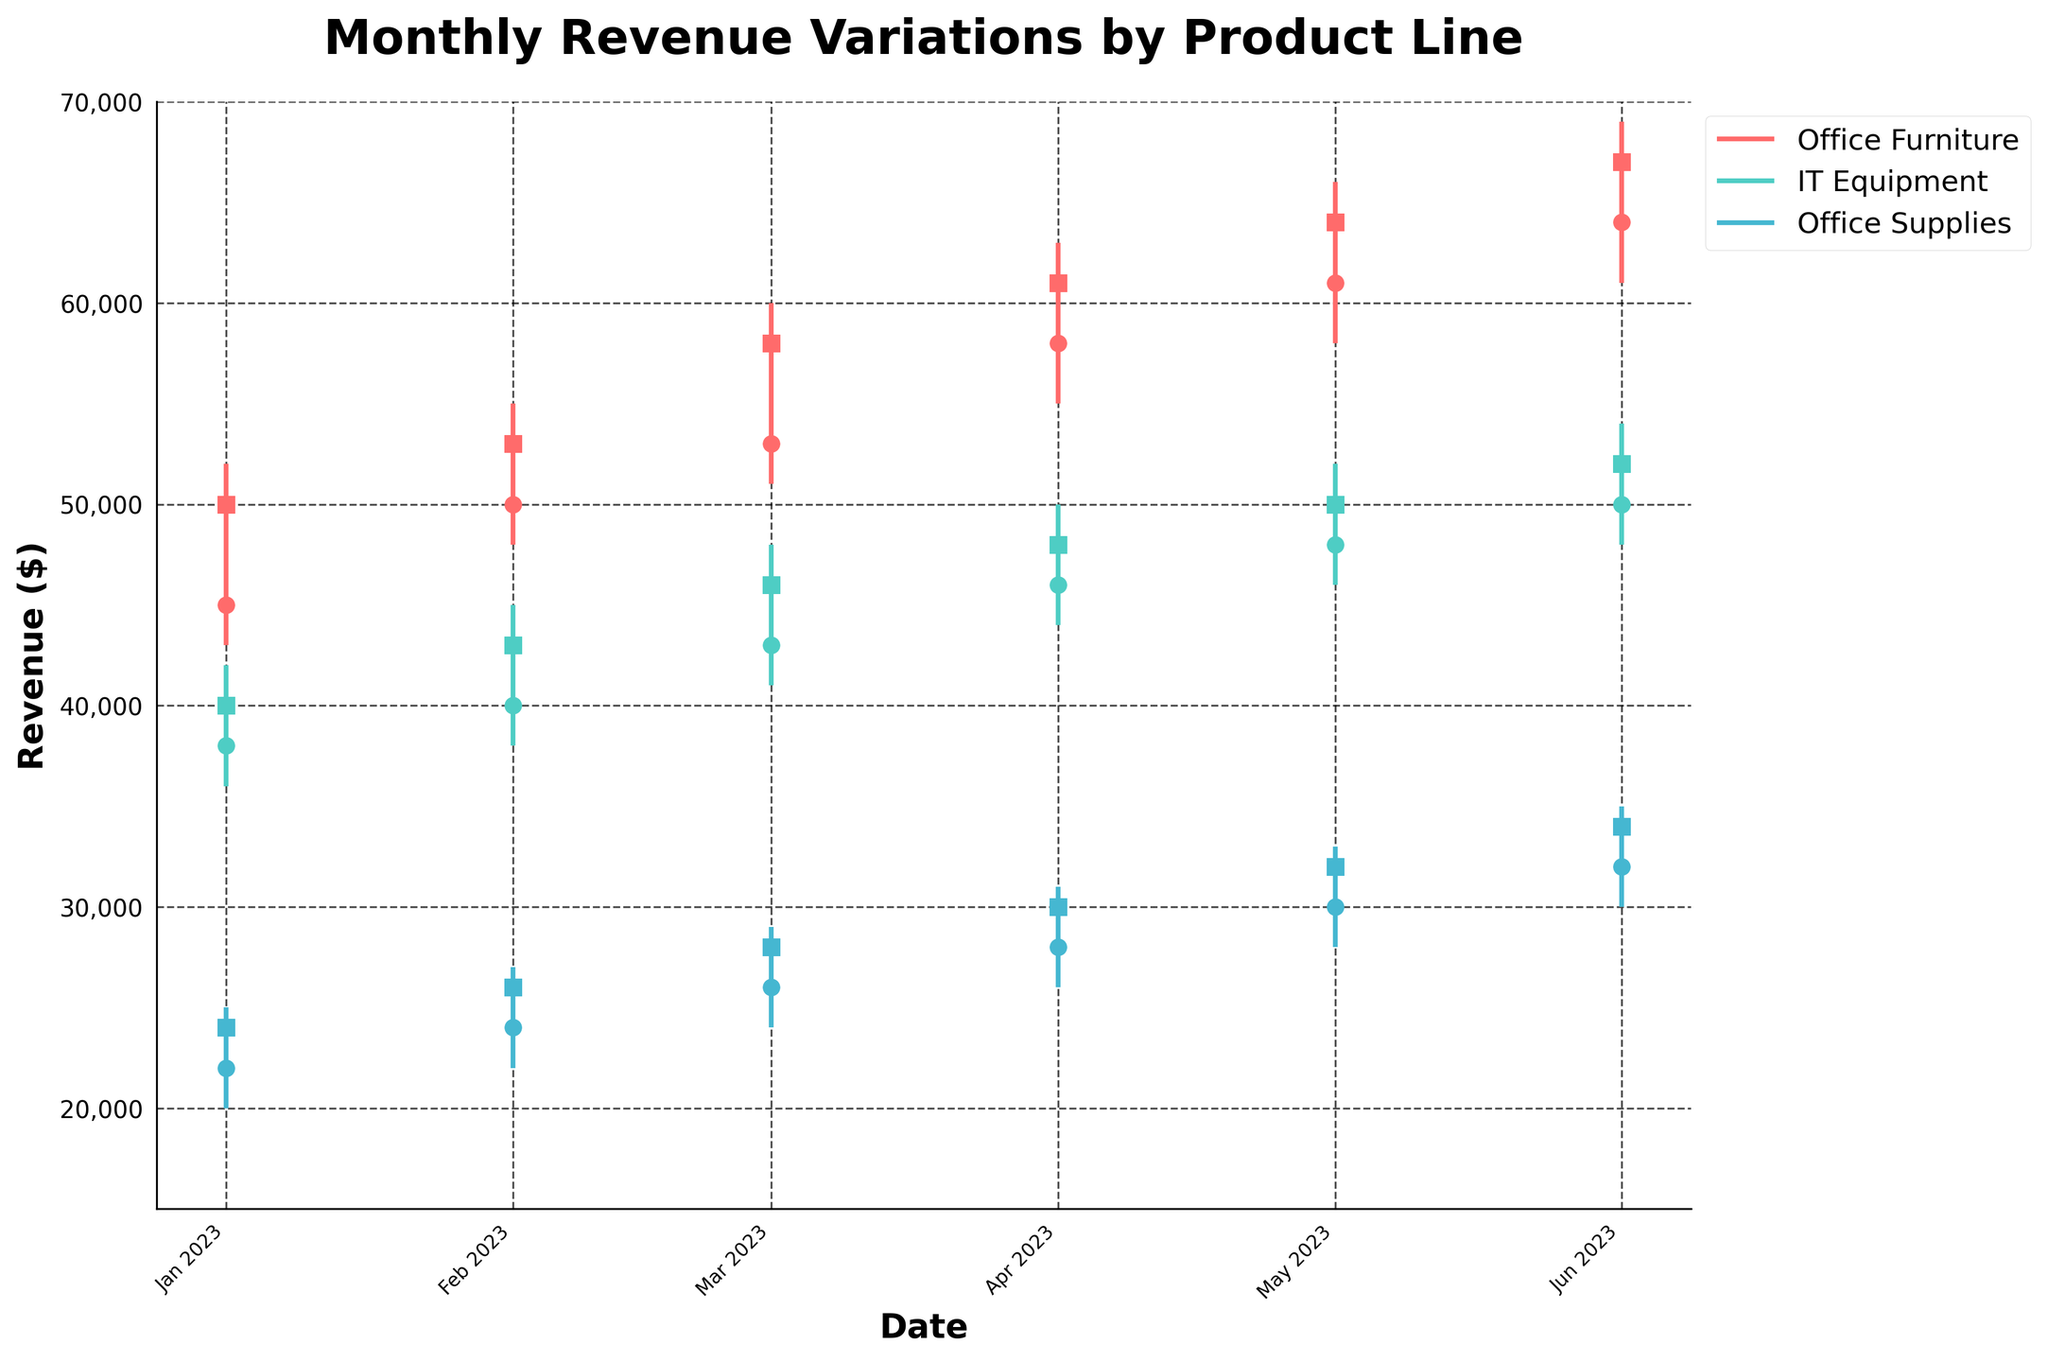What's the highest revenue achieved by IT Equipment within the given months? To find the highest revenue for IT Equipment, we need to look at the "High" values for the IT Equipment product line. The highest value in the "High" column for IT Equipment is 54,000.
Answer: 54,000 Which product had the highest revenue in March 2023? For March 2023, look at the "High" values for each product. Office Furniture had a high of 60,000, IT Equipment had a high of 48,000, and Office Supplies had a high of 29,000. Office Furniture had the highest revenue in March 2023.
Answer: Office Furniture What is the average closing revenue of Office Supplies from January to June 2023? Add the closing revenues for Office Supplies from January to June (24,000 + 26,000 + 28,000 + 30,000 + 32,000 + 34,000) and divide by 6. The sum is 174,000, and the average is 174,000 / 6 = 29,000.
Answer: 29,000 Between January and June 2023, did IT Equipment's revenue ever surpass Office Furniture's revenue? Compare the "High" values for IT Equipment and Office Furniture for each month. IT Equipment's highest "High" value is 54,000, while Office Furniture's lowest "High" value is 52,000. Thus, IT Equipment's revenue never surpassed Office Furniture's revenue.
Answer: No In which month did Office Furniture see the most significant increase in closing revenue compared to the previous month? Compare the closing revenue month-over-month for Office Furniture. January to February (50,000 to 53,000 is +3,000), February to March (+5,000), March to April (+3,000), April to May (+3,000), May to June (+3,000). March saw the most significant increase from February (+5,000).
Answer: March Which product experienced the most stable revenue in terms of the smallest fluctuation between high and low values in May 2023? Calculate the difference between "High" and "Low" for each product in May: Office Furniture (66,000 - 58,000 = 8,000), IT Equipment (52,000 - 46,000 = 6,000), Office Supplies (33,000 - 28,000 = 5,000). Office Supplies experienced the smallest fluctuation.
Answer: Office Supplies How did IT Equipment's closing revenue change from January to June 2023? Look at the closing values for IT Equipment: January 40,000, February 43,000, March 46,000, April 48,000, May 50,000, June 52,000. The closing revenue increased consistently each month.
Answer: Increased Which product showed the highest open value in June 2023? Look at the open values for each product in June 2023: Office Furniture 64,000, IT Equipment 50,000, Office Supplies 32,000. Office Furniture showed the highest open value.
Answer: Office Furniture What was the closing revenue of Office Supplies in April 2023? Check the "Close" column for Office Supplies in April 2023, which is 30,000.
Answer: 30,000 